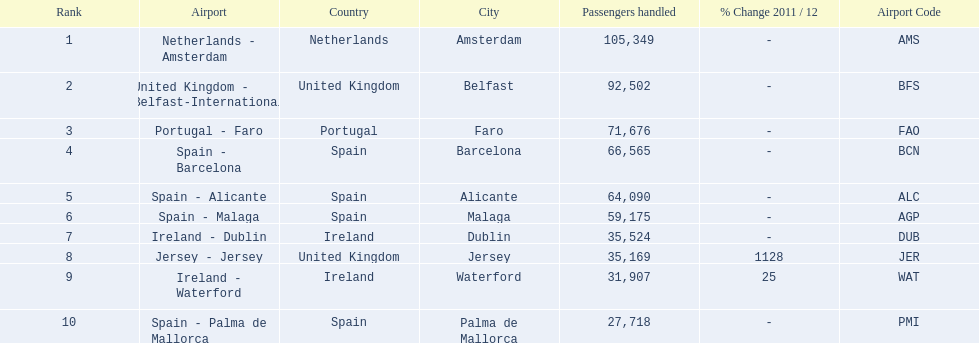What are all of the destinations out of the london southend airport? Netherlands - Amsterdam, United Kingdom - Belfast-International, Portugal - Faro, Spain - Barcelona, Spain - Alicante, Spain - Malaga, Ireland - Dublin, Jersey - Jersey, Ireland - Waterford, Spain - Palma de Mallorca. How many passengers has each destination handled? 105,349, 92,502, 71,676, 66,565, 64,090, 59,175, 35,524, 35,169, 31,907, 27,718. And of those, which airport handled the fewest passengers? Spain - Palma de Mallorca. 